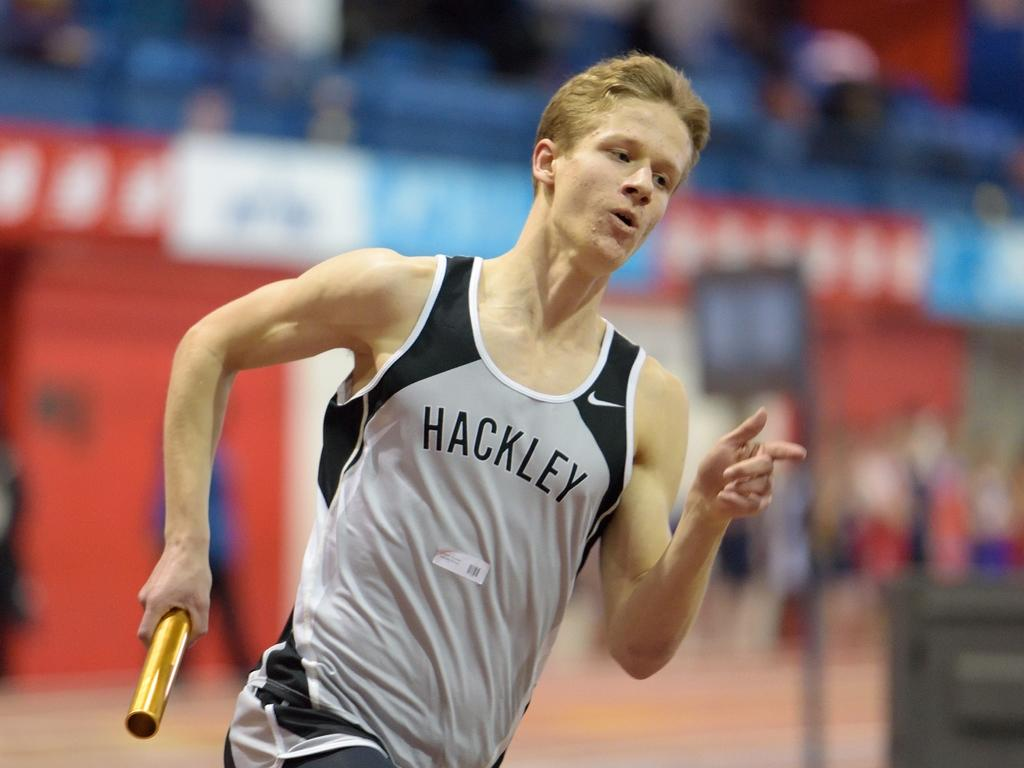<image>
Relay a brief, clear account of the picture shown. Man wearing Hackley jersey running a race while holding a baton. 